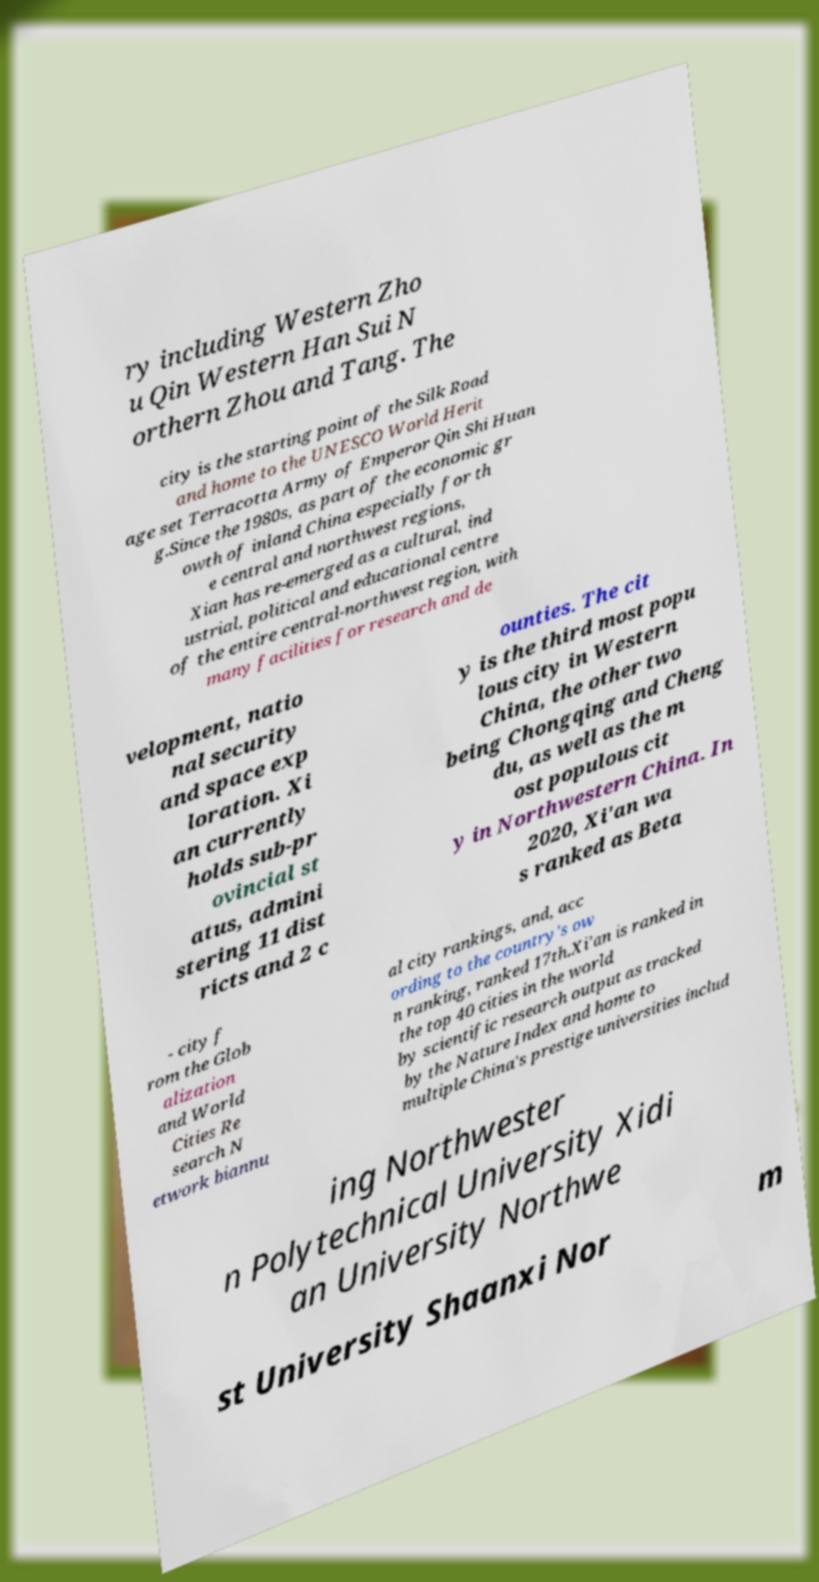Can you read and provide the text displayed in the image?This photo seems to have some interesting text. Can you extract and type it out for me? ry including Western Zho u Qin Western Han Sui N orthern Zhou and Tang. The city is the starting point of the Silk Road and home to the UNESCO World Herit age set Terracotta Army of Emperor Qin Shi Huan g.Since the 1980s, as part of the economic gr owth of inland China especially for th e central and northwest regions, Xian has re-emerged as a cultural, ind ustrial, political and educational centre of the entire central-northwest region, with many facilities for research and de velopment, natio nal security and space exp loration. Xi an currently holds sub-pr ovincial st atus, admini stering 11 dist ricts and 2 c ounties. The cit y is the third most popu lous city in Western China, the other two being Chongqing and Cheng du, as well as the m ost populous cit y in Northwestern China. In 2020, Xi'an wa s ranked as Beta - city f rom the Glob alization and World Cities Re search N etwork biannu al city rankings, and, acc ording to the country's ow n ranking, ranked 17th.Xi'an is ranked in the top 40 cities in the world by scientific research output as tracked by the Nature Index and home to multiple China's prestige universities includ ing Northwester n Polytechnical University Xidi an University Northwe st University Shaanxi Nor m 